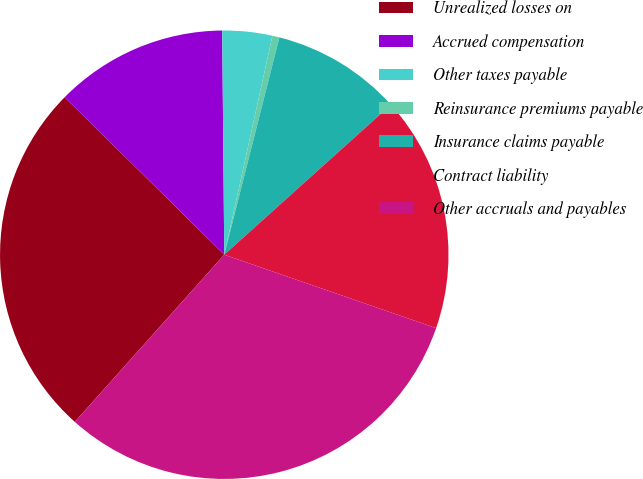<chart> <loc_0><loc_0><loc_500><loc_500><pie_chart><fcel>Unrealized losses on<fcel>Accrued compensation<fcel>Other taxes payable<fcel>Reinsurance premiums payable<fcel>Insurance claims payable<fcel>Contract liability<fcel>Other accruals and payables<nl><fcel>25.78%<fcel>12.46%<fcel>3.59%<fcel>0.51%<fcel>9.38%<fcel>16.97%<fcel>31.3%<nl></chart> 